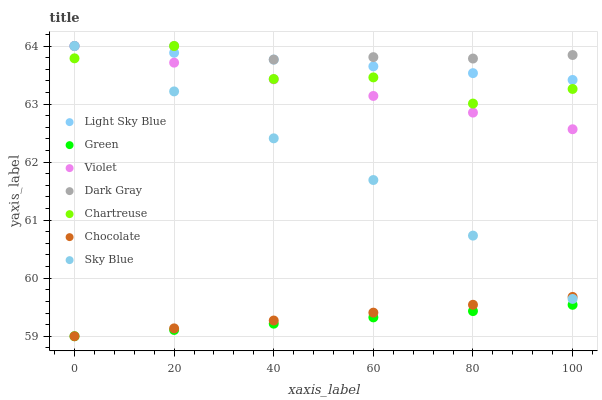Does Green have the minimum area under the curve?
Answer yes or no. Yes. Does Dark Gray have the maximum area under the curve?
Answer yes or no. Yes. Does Chartreuse have the minimum area under the curve?
Answer yes or no. No. Does Chartreuse have the maximum area under the curve?
Answer yes or no. No. Is Chocolate the smoothest?
Answer yes or no. Yes. Is Chartreuse the roughest?
Answer yes or no. Yes. Is Dark Gray the smoothest?
Answer yes or no. No. Is Dark Gray the roughest?
Answer yes or no. No. Does Chocolate have the lowest value?
Answer yes or no. Yes. Does Chartreuse have the lowest value?
Answer yes or no. No. Does Sky Blue have the highest value?
Answer yes or no. Yes. Does Green have the highest value?
Answer yes or no. No. Is Chocolate less than Dark Gray?
Answer yes or no. Yes. Is Sky Blue greater than Green?
Answer yes or no. Yes. Does Light Sky Blue intersect Chartreuse?
Answer yes or no. Yes. Is Light Sky Blue less than Chartreuse?
Answer yes or no. No. Is Light Sky Blue greater than Chartreuse?
Answer yes or no. No. Does Chocolate intersect Dark Gray?
Answer yes or no. No. 